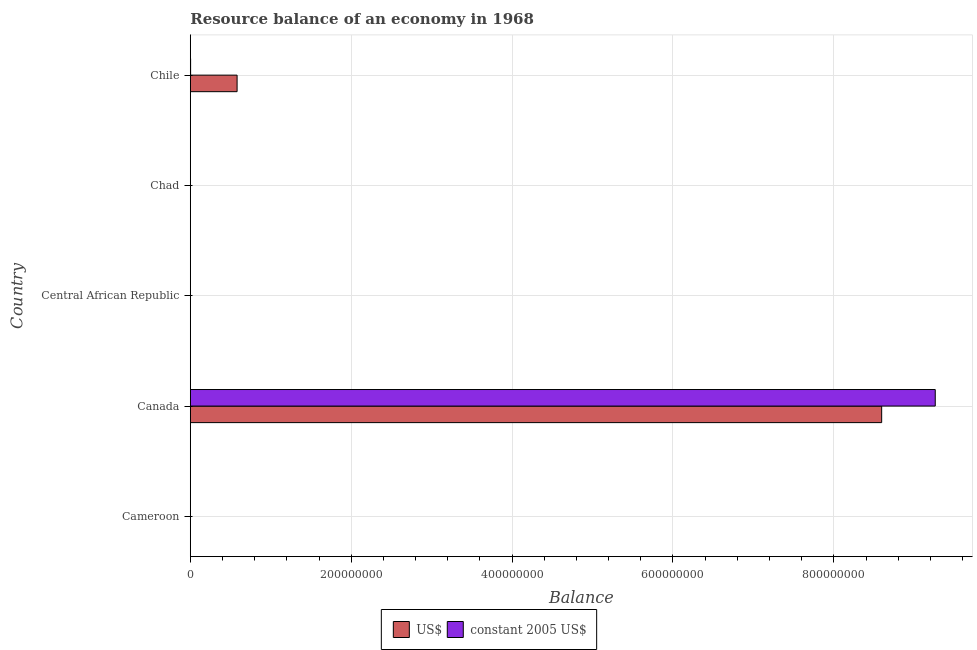How many different coloured bars are there?
Ensure brevity in your answer.  2. Are the number of bars on each tick of the Y-axis equal?
Your response must be concise. No. How many bars are there on the 3rd tick from the bottom?
Provide a succinct answer. 0. What is the resource balance in us$ in Canada?
Your response must be concise. 8.59e+08. Across all countries, what is the maximum resource balance in constant us$?
Offer a terse response. 9.26e+08. Across all countries, what is the minimum resource balance in us$?
Ensure brevity in your answer.  0. What is the total resource balance in constant us$ in the graph?
Provide a short and direct response. 9.26e+08. What is the difference between the resource balance in constant us$ in Canada and that in Chile?
Ensure brevity in your answer.  9.26e+08. What is the difference between the resource balance in us$ in Canada and the resource balance in constant us$ in Chad?
Ensure brevity in your answer.  8.59e+08. What is the average resource balance in us$ per country?
Provide a short and direct response. 1.84e+08. What is the difference between the resource balance in us$ and resource balance in constant us$ in Chile?
Provide a succinct answer. 5.78e+07. What is the ratio of the resource balance in constant us$ in Canada to that in Chile?
Make the answer very short. 2315. What is the difference between the highest and the lowest resource balance in us$?
Make the answer very short. 8.59e+08. Are the values on the major ticks of X-axis written in scientific E-notation?
Your answer should be compact. No. Does the graph contain any zero values?
Provide a short and direct response. Yes. Does the graph contain grids?
Provide a succinct answer. Yes. Where does the legend appear in the graph?
Offer a terse response. Bottom center. How many legend labels are there?
Keep it short and to the point. 2. How are the legend labels stacked?
Keep it short and to the point. Horizontal. What is the title of the graph?
Keep it short and to the point. Resource balance of an economy in 1968. What is the label or title of the X-axis?
Offer a terse response. Balance. What is the Balance in constant 2005 US$ in Cameroon?
Your answer should be very brief. 0. What is the Balance of US$ in Canada?
Give a very brief answer. 8.59e+08. What is the Balance in constant 2005 US$ in Canada?
Offer a terse response. 9.26e+08. What is the Balance in US$ in Central African Republic?
Ensure brevity in your answer.  0. What is the Balance in US$ in Chile?
Give a very brief answer. 5.82e+07. What is the Balance of constant 2005 US$ in Chile?
Keep it short and to the point. 4.00e+05. Across all countries, what is the maximum Balance in US$?
Provide a succinct answer. 8.59e+08. Across all countries, what is the maximum Balance of constant 2005 US$?
Offer a terse response. 9.26e+08. Across all countries, what is the minimum Balance of US$?
Your answer should be very brief. 0. What is the total Balance of US$ in the graph?
Ensure brevity in your answer.  9.18e+08. What is the total Balance in constant 2005 US$ in the graph?
Give a very brief answer. 9.26e+08. What is the difference between the Balance in US$ in Canada and that in Chile?
Keep it short and to the point. 8.01e+08. What is the difference between the Balance in constant 2005 US$ in Canada and that in Chile?
Provide a short and direct response. 9.26e+08. What is the difference between the Balance of US$ in Canada and the Balance of constant 2005 US$ in Chile?
Offer a very short reply. 8.59e+08. What is the average Balance in US$ per country?
Provide a short and direct response. 1.84e+08. What is the average Balance of constant 2005 US$ per country?
Offer a very short reply. 1.85e+08. What is the difference between the Balance in US$ and Balance in constant 2005 US$ in Canada?
Make the answer very short. -6.66e+07. What is the difference between the Balance in US$ and Balance in constant 2005 US$ in Chile?
Your answer should be compact. 5.78e+07. What is the ratio of the Balance in US$ in Canada to that in Chile?
Give a very brief answer. 14.77. What is the ratio of the Balance of constant 2005 US$ in Canada to that in Chile?
Your answer should be very brief. 2315. What is the difference between the highest and the lowest Balance of US$?
Ensure brevity in your answer.  8.59e+08. What is the difference between the highest and the lowest Balance in constant 2005 US$?
Keep it short and to the point. 9.26e+08. 